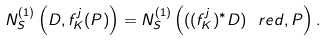Convert formula to latex. <formula><loc_0><loc_0><loc_500><loc_500>N _ { S } ^ { ( 1 ) } \left ( D , f _ { K } ^ { j } ( P ) \right ) = N _ { S } ^ { ( 1 ) } \left ( ( ( f _ { K } ^ { j } ) ^ { * } D ) ^ { \ } r e d , P \right ) .</formula> 